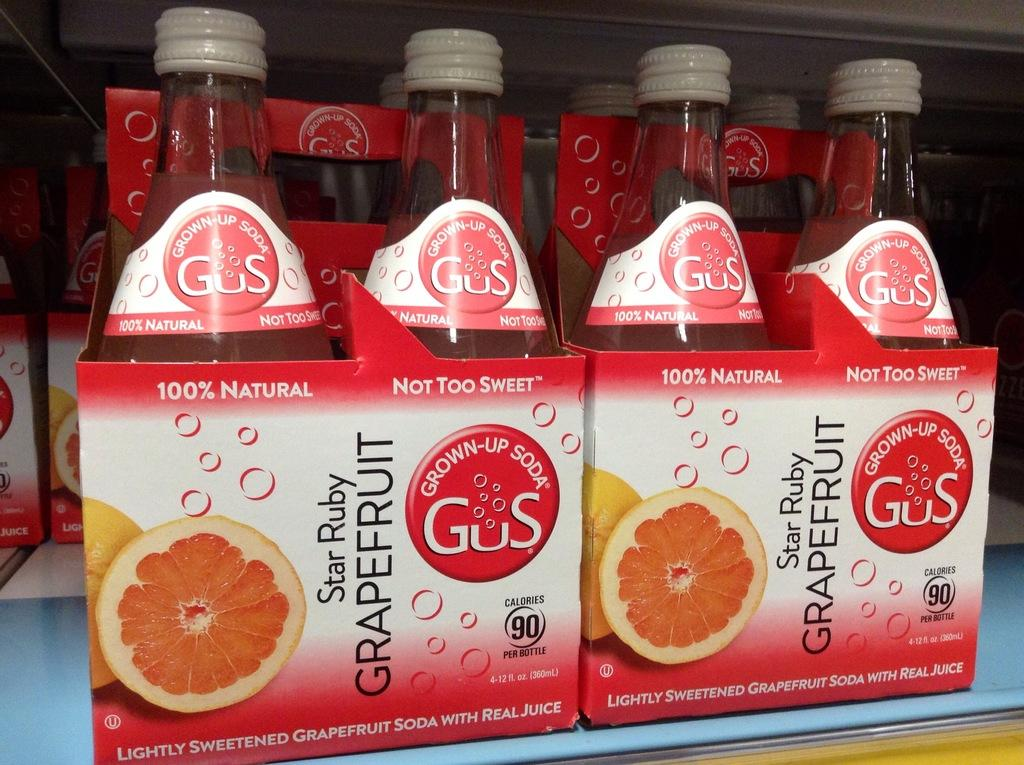What objects are arranged in a group in the image? There is a group of bottles in the image. How are the bottles positioned in the image? The bottles are kept on boxes. What can be seen on the boxes that the bottles are placed on? There is text written on the boxes. What is the colorful item visible in the image? There is a piece of orange in the image. How can the bottles be identified individually? Each bottle has a label attached to it. What type of humor can be seen in the image? There is no humor present in the image; it features a group of bottles on boxes with text and a piece of orange. 